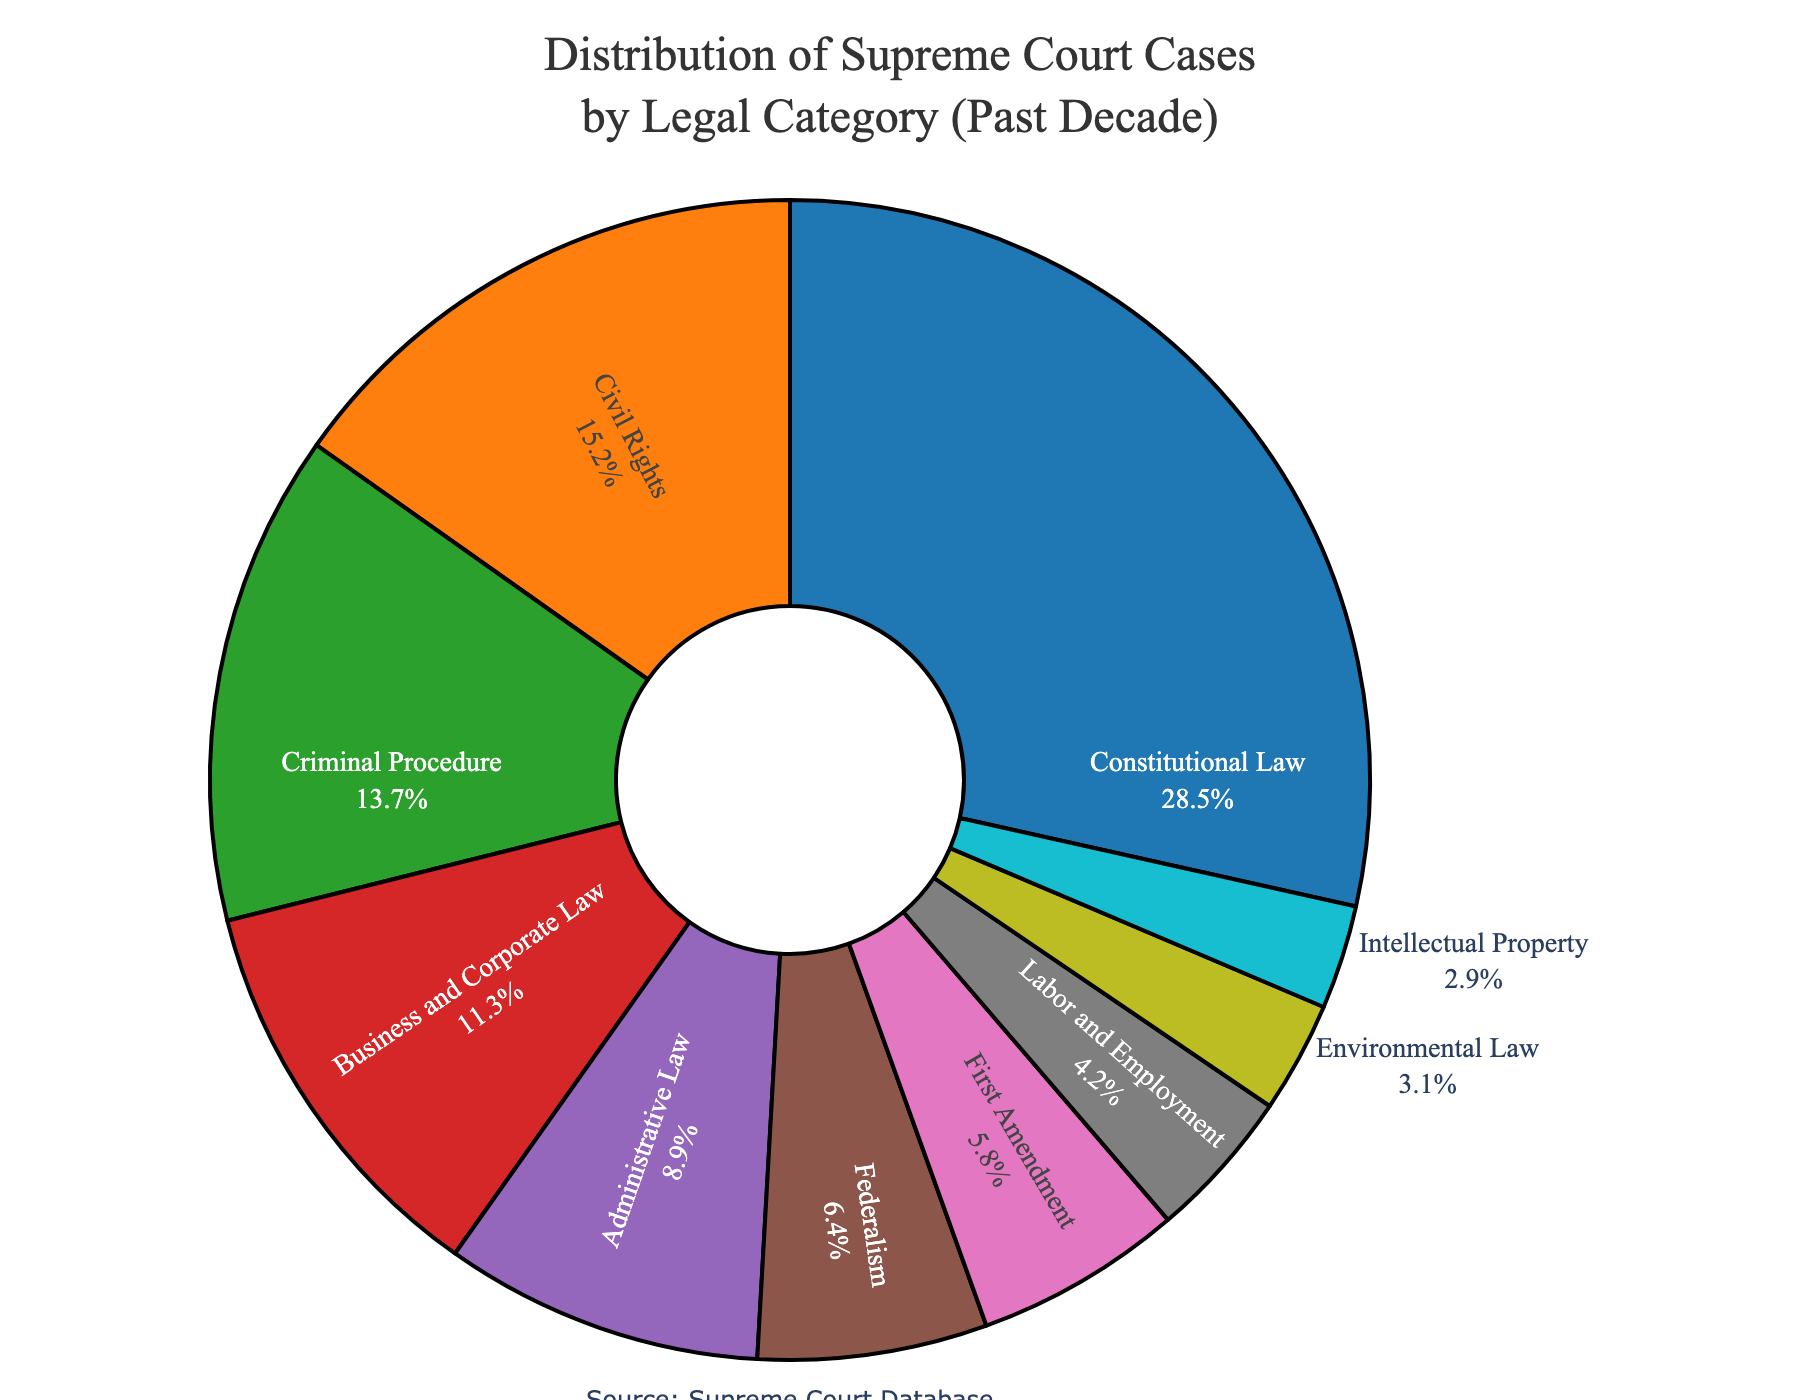What's the largest legal category by percentage in Supreme Court cases? To find the largest category, look for the segment with the highest percentage. The "Constitutional Law" category shows the largest portion at 28.5%.
Answer: Constitutional Law What is the total percentage of cases in Civil Rights and Criminal Procedure combined? Add the percentages for these two categories. Civil Rights is 15.2% and Criminal Procedure is 13.7%, so 15.2% + 13.7% equals 28.9%.
Answer: 28.9% Which legal category has a smaller percentage of cases, Environmental Law or Intellectual Property? Compare the percentages of Environmental Law (3.1%) and Intellectual Property (2.9%). The latter is smaller.
Answer: Intellectual Property How many categories have a percentage lower than 10%? Count the categories with percentages less than 10: Administrative Law (8.9%), Federalism (6.4%), First Amendment (5.8%), Labor and Employment (4.2%), Environmental Law (3.1%), and Intellectual Property (2.9%). There are six categories.
Answer: 6 Are there any legal categories with exactly the same percentage of cases? Check each category's value. None of the percentages are the same across the categories listed.
Answer: No What's the average percentage of cases among Business and Corporate Law, Labor and Employment, and First Amendment? Add the percentages for the three categories and divide by 3. Business and Corporate Law is 11.3%, Labor and Employment is 4.2%, and First Amendment is 5.8%. Calculate (11.3 + 4.2 + 5.8) / 3 = 7.1%.
Answer: 7.1% Which legal category slice is colored in green, based on the color legend provided? The provided code assigns green to the third color, corresponding to "Criminal Procedure" at 13.7%.
Answer: Criminal Procedure By how much does the percentage of First Amendment cases differ from Federalism cases? Subtract the smaller percentage (Federalism) from the larger percentage (First Amendment). First Amendment is 5.8% and Federalism is 6.4%, so 6.4% - 5.8% = 0.6%.
Answer: 0.6% What is the combined percentage of Administrative Law and Business and Corporate Law cases? Add the percentages for these two categories. Administrative Law is 8.9% and Business and Corporate Law is 11.3%, so 8.9% + 11.3% = 20.2%.
Answer: 20.2% Which category follows Business and Corporate Law in percentage size when ordered from largest to smallest? The next highest category after Business and Corporate Law (11.3%) is Criminal Procedure at 13.7%.
Answer: Criminal Procedure 